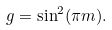Convert formula to latex. <formula><loc_0><loc_0><loc_500><loc_500>g = \sin ^ { 2 } ( \pi m ) .</formula> 